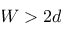<formula> <loc_0><loc_0><loc_500><loc_500>W > 2 d</formula> 